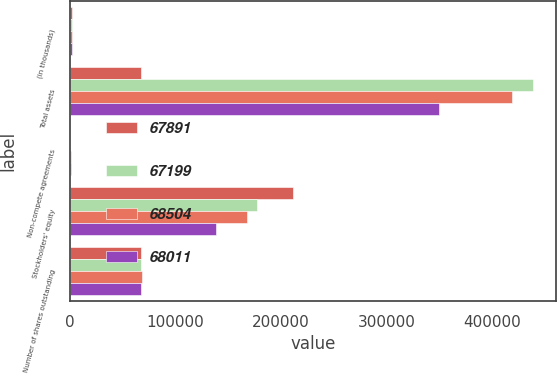Convert chart to OTSL. <chart><loc_0><loc_0><loc_500><loc_500><stacked_bar_chart><ecel><fcel>(in thousands)<fcel>Total assets<fcel>Non-compete agreements<fcel>Stockholders' equity<fcel>Number of shares outstanding<nl><fcel>67891<fcel>2006<fcel>67891<fcel>660<fcel>211459<fcel>67891<nl><fcel>67199<fcel>2005<fcel>438420<fcel>456<fcel>176951<fcel>68011<nl><fcel>68504<fcel>2004<fcel>418780<fcel>1700<fcel>167549<fcel>68504<nl><fcel>68011<fcel>2003<fcel>349904<fcel>1734<fcel>138774<fcel>67735<nl></chart> 